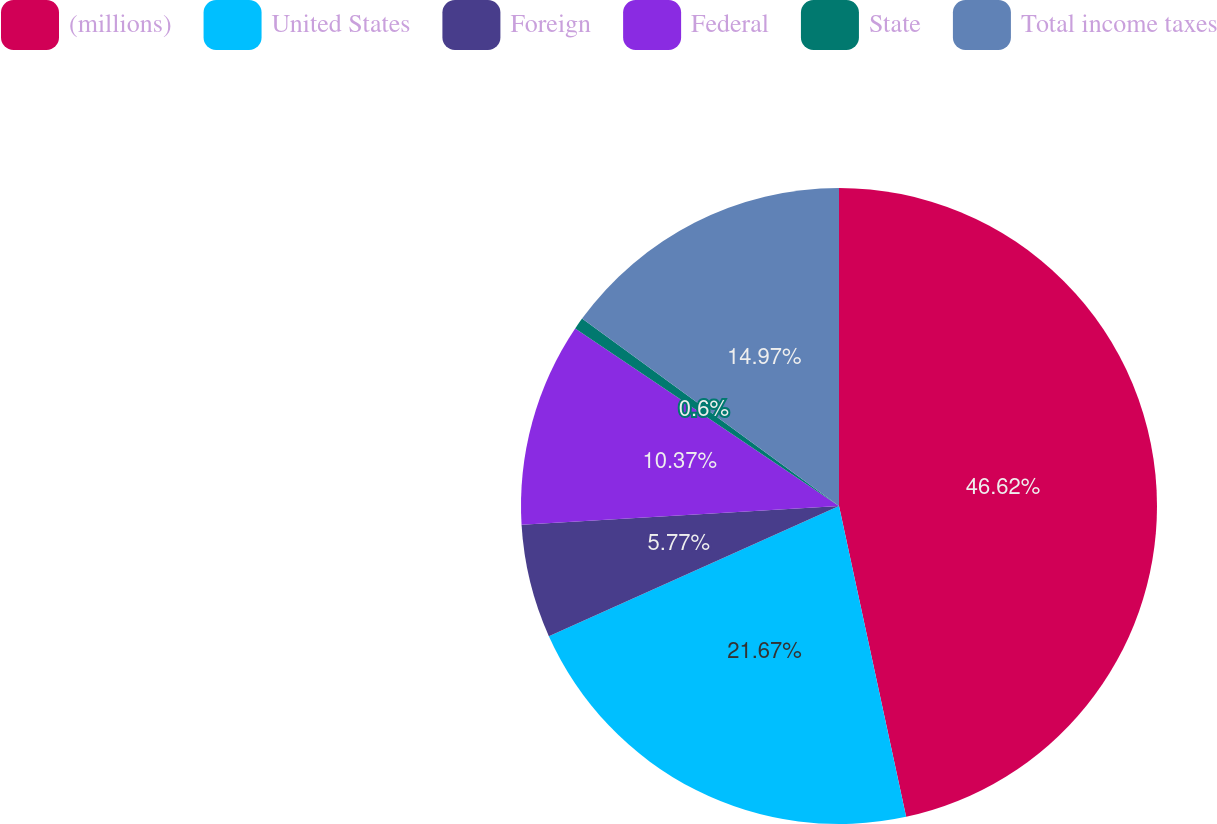Convert chart. <chart><loc_0><loc_0><loc_500><loc_500><pie_chart><fcel>(millions)<fcel>United States<fcel>Foreign<fcel>Federal<fcel>State<fcel>Total income taxes<nl><fcel>46.61%<fcel>21.67%<fcel>5.77%<fcel>10.37%<fcel>0.6%<fcel>14.97%<nl></chart> 